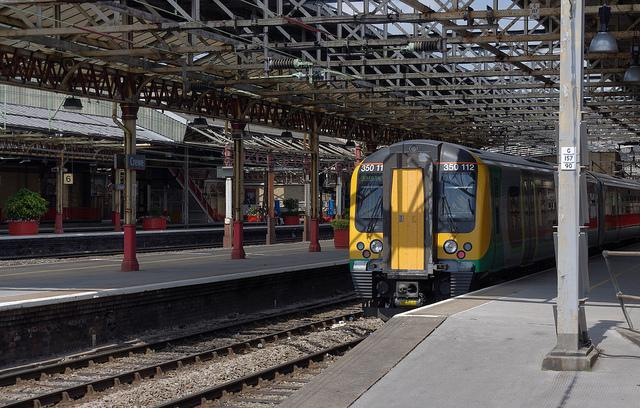Which numbers are fully visible on both the top left and top right of the front of the bus? Please explain your reasoning. 350. The combination of 3, 5 and 0 can be seen on both sides. 